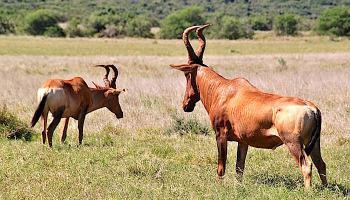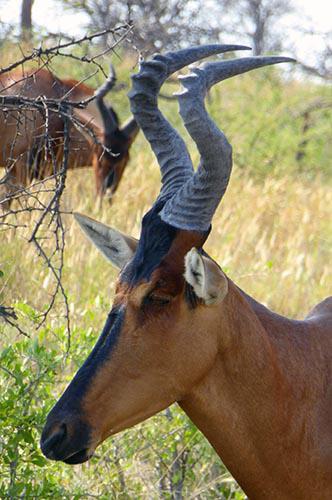The first image is the image on the left, the second image is the image on the right. For the images shown, is this caption "There are more than two horned animals in the grassy field." true? Answer yes or no. Yes. 